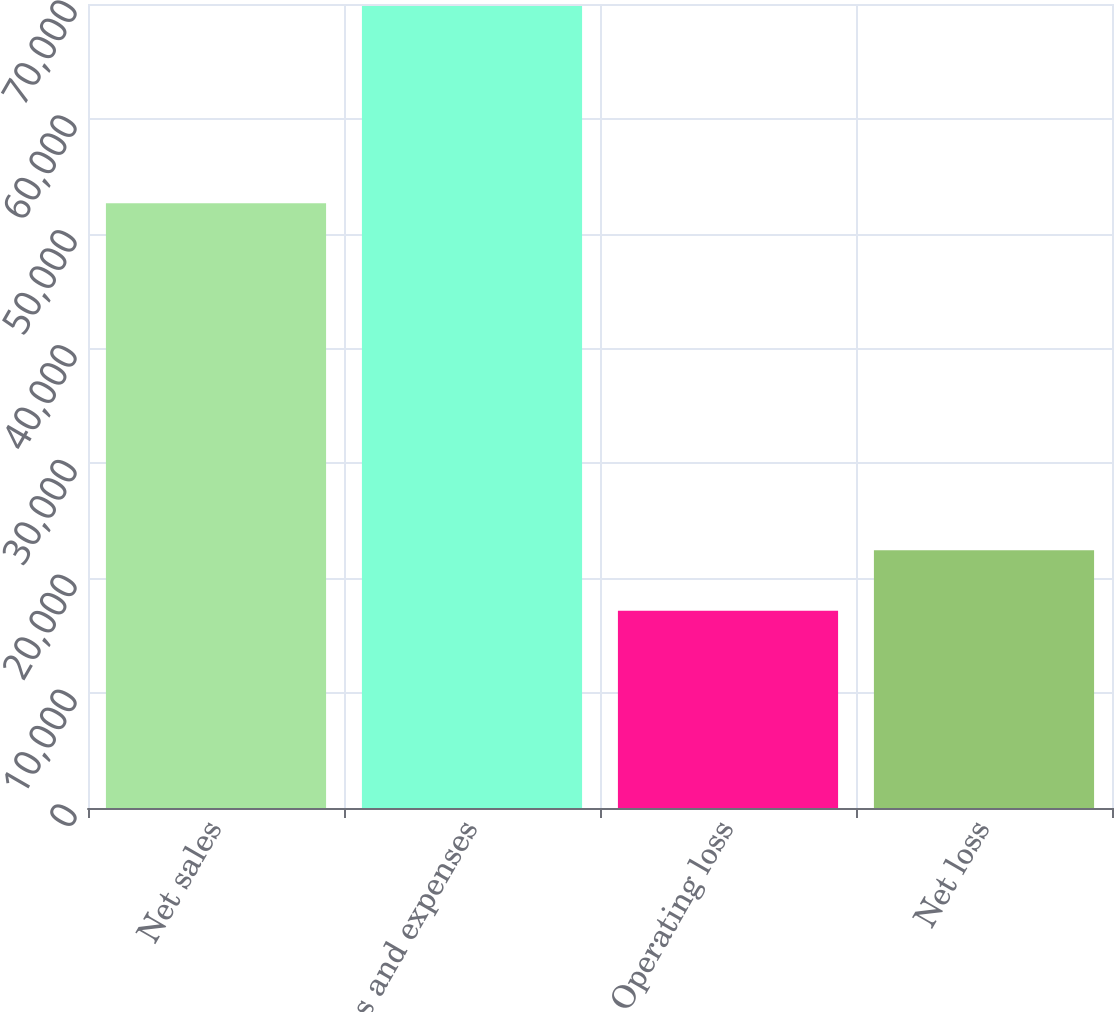Convert chart. <chart><loc_0><loc_0><loc_500><loc_500><bar_chart><fcel>Net sales<fcel>Costs and expenses<fcel>Operating loss<fcel>Net loss<nl><fcel>52643<fcel>69825<fcel>17182<fcel>22446.3<nl></chart> 